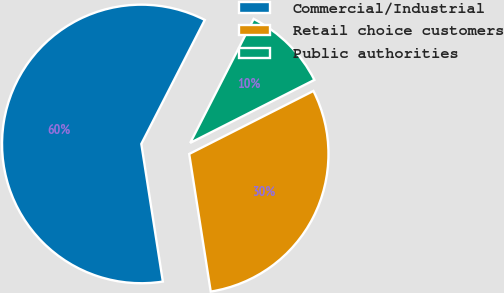<chart> <loc_0><loc_0><loc_500><loc_500><pie_chart><fcel>Commercial/Industrial<fcel>Retail choice customers<fcel>Public authorities<nl><fcel>60.0%<fcel>30.0%<fcel>10.0%<nl></chart> 